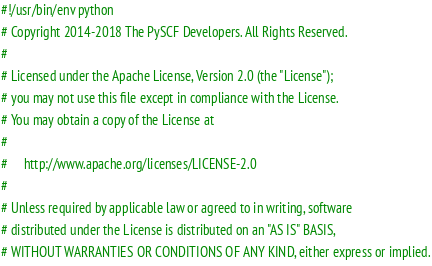Convert code to text. <code><loc_0><loc_0><loc_500><loc_500><_Python_>#!/usr/bin/env python
# Copyright 2014-2018 The PySCF Developers. All Rights Reserved.
#
# Licensed under the Apache License, Version 2.0 (the "License");
# you may not use this file except in compliance with the License.
# You may obtain a copy of the License at
#
#     http://www.apache.org/licenses/LICENSE-2.0
#
# Unless required by applicable law or agreed to in writing, software
# distributed under the License is distributed on an "AS IS" BASIS,
# WITHOUT WARRANTIES OR CONDITIONS OF ANY KIND, either express or implied.</code> 